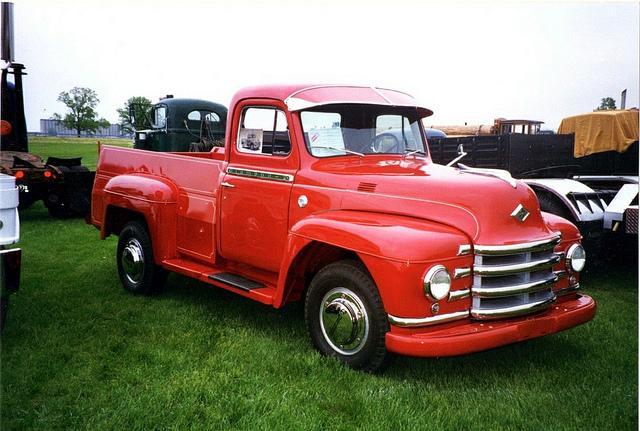How many brake lights are in this photo?
Short answer required. 2. Is this a fire truck?
Concise answer only. No. What color is this truck?
Quick response, please. Red. What type of tree is behind the truck?
Short answer required. Oak. 